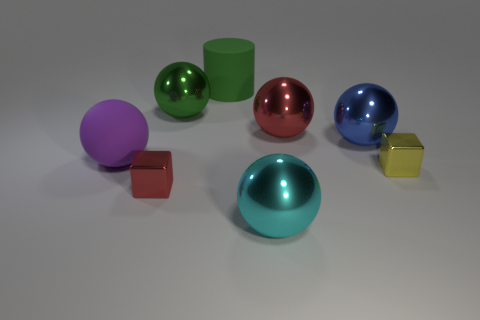There is a metallic thing that is to the right of the red metallic ball and left of the yellow object; what is its size?
Your response must be concise. Large. Are there fewer metal blocks that are right of the green rubber cylinder than big things?
Offer a very short reply. Yes. There is a green thing that is made of the same material as the yellow cube; what shape is it?
Your response must be concise. Sphere. Does the big thing in front of the tiny yellow shiny block have the same shape as the small metallic object left of the green shiny object?
Offer a terse response. No. Are there fewer blue shiny spheres that are in front of the yellow block than metallic cubes that are on the left side of the blue thing?
Make the answer very short. Yes. What number of cyan shiny objects have the same size as the green matte object?
Your answer should be very brief. 1. Do the tiny thing that is to the left of the large red metal thing and the large cylinder have the same material?
Ensure brevity in your answer.  No. Are any brown metallic balls visible?
Offer a terse response. No. What is the size of the red block that is the same material as the large green sphere?
Provide a succinct answer. Small. Is there a large metal sphere that has the same color as the large cylinder?
Ensure brevity in your answer.  Yes. 